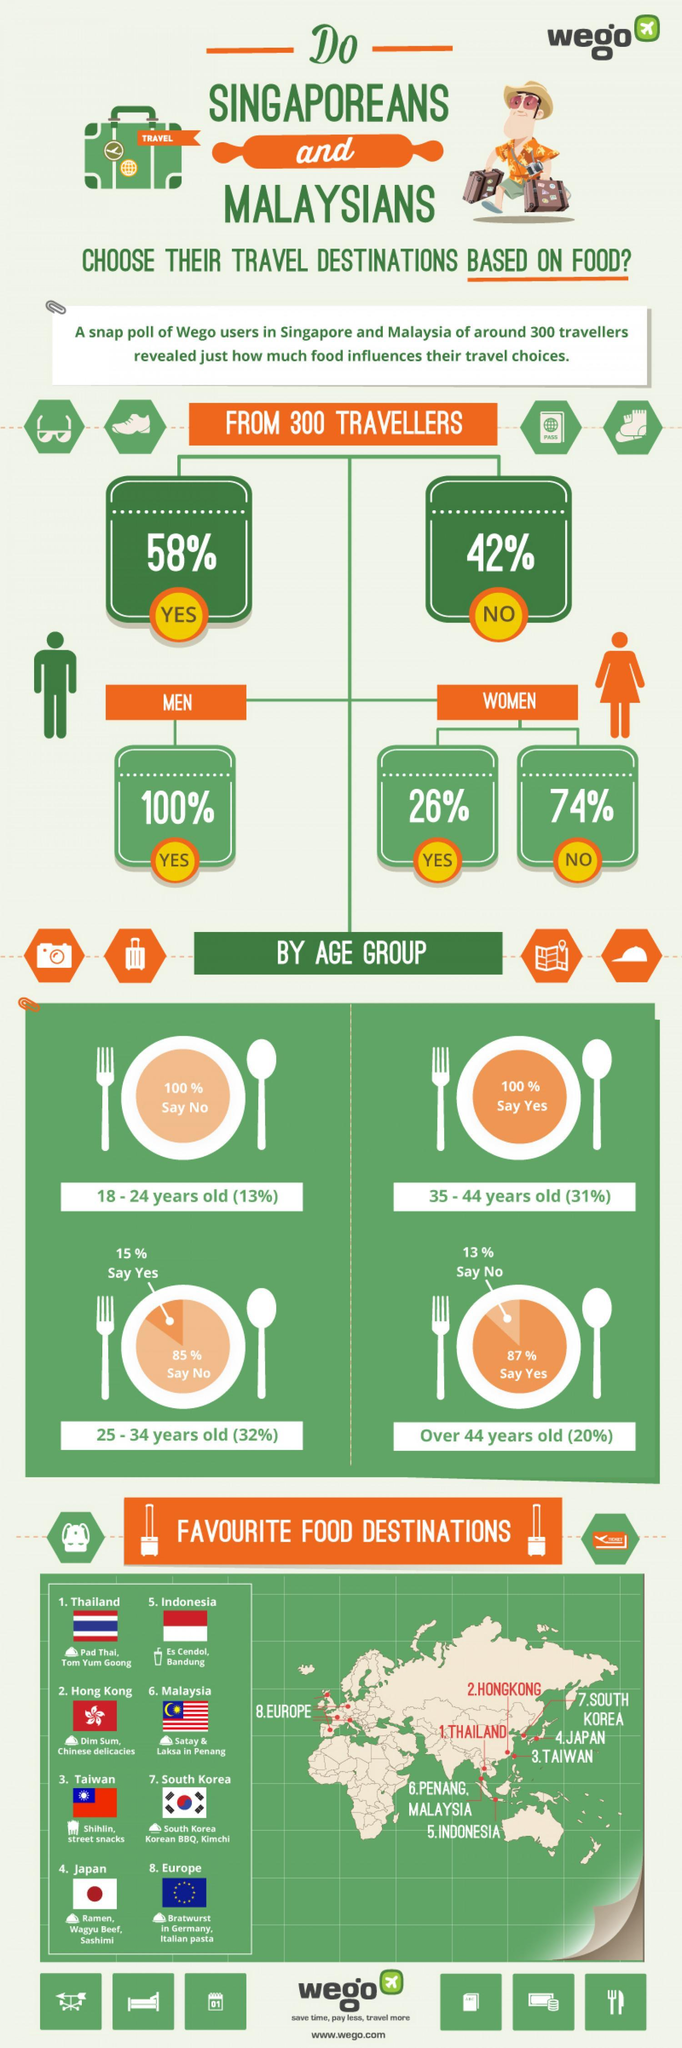What percentage of people aged between 25-34 choose travel destinations based on food, 85%, 32%, or 15%?
Answer the question with a short phrase. 15% Which continent ranks eighth in the list of food destinations, Asia, Europe, or America ? Europe What percentage of people over the age of 44 do not choose travel destinations based on food, 13%, 87%, or 20%? 13% What percentage of people between the age group 18-24 choose travel destinations based on food, 100%, 13%, or None? None What percentage of people between the age group 35-44 do not choose travel destinations based on food, 100%, 31%, or None? None Which continent does the first seven food destinations belong to, Europe, America, or Asia? Asia What percentage of women choose travel destinations based on food, 100%, 26%, or 74%? 26% What percentage of Wego users do not choose travel destinations based on food, 58%, 42%, or 26%? 42% Which two countries rank the highest in the food destination list? Thailand, Hong Kong 